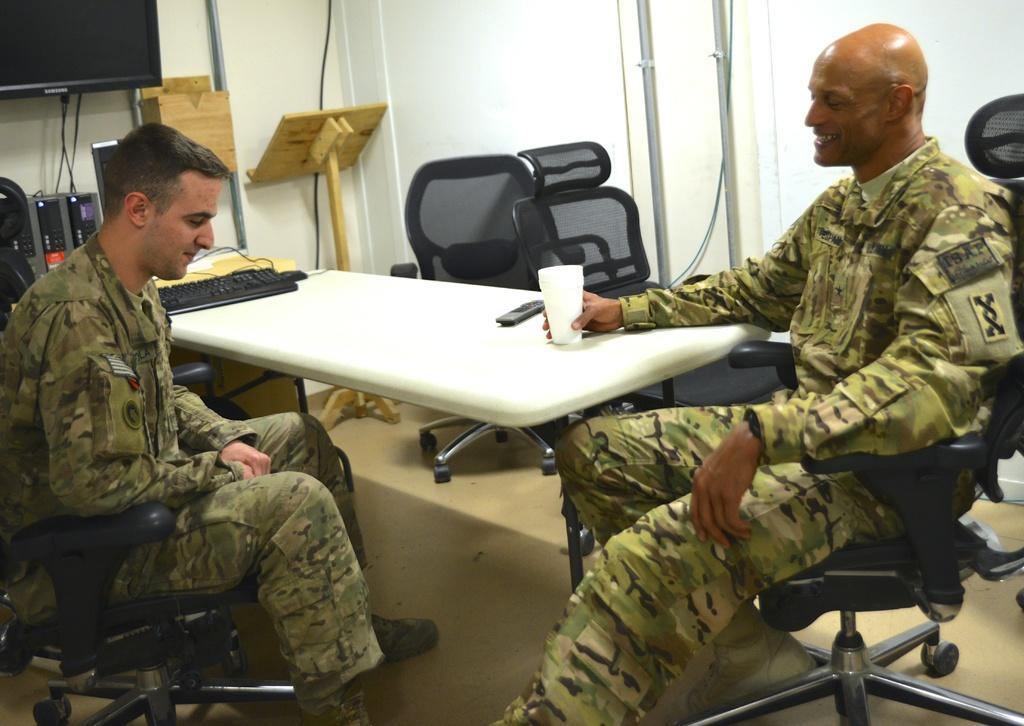Could you give a brief overview of what you see in this image? In this picture I can see on the right side there is a man, he is talking and also holding a glass with his hand. On the left side there is a man sitting on the chair, he is wearing an army dress. In the top left hand side corner there is a t. v. on the wall. In the middle there is a table and there are chairs. 